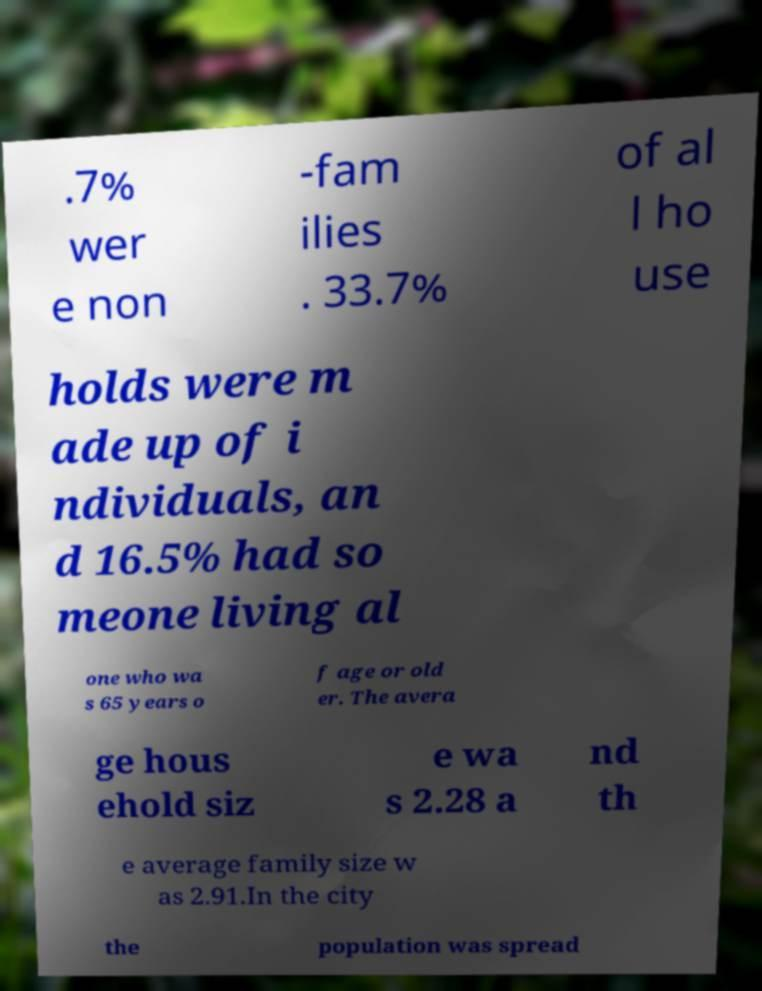There's text embedded in this image that I need extracted. Can you transcribe it verbatim? .7% wer e non -fam ilies . 33.7% of al l ho use holds were m ade up of i ndividuals, an d 16.5% had so meone living al one who wa s 65 years o f age or old er. The avera ge hous ehold siz e wa s 2.28 a nd th e average family size w as 2.91.In the city the population was spread 